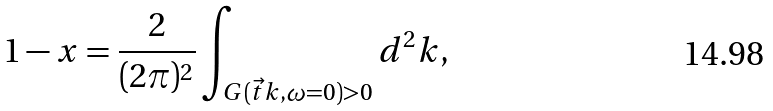<formula> <loc_0><loc_0><loc_500><loc_500>1 - x = \frac { 2 } { ( 2 \pi ) ^ { 2 } } \int _ { G ( \vec { t } { k } , \omega = 0 ) > 0 } d ^ { 2 } k ,</formula> 